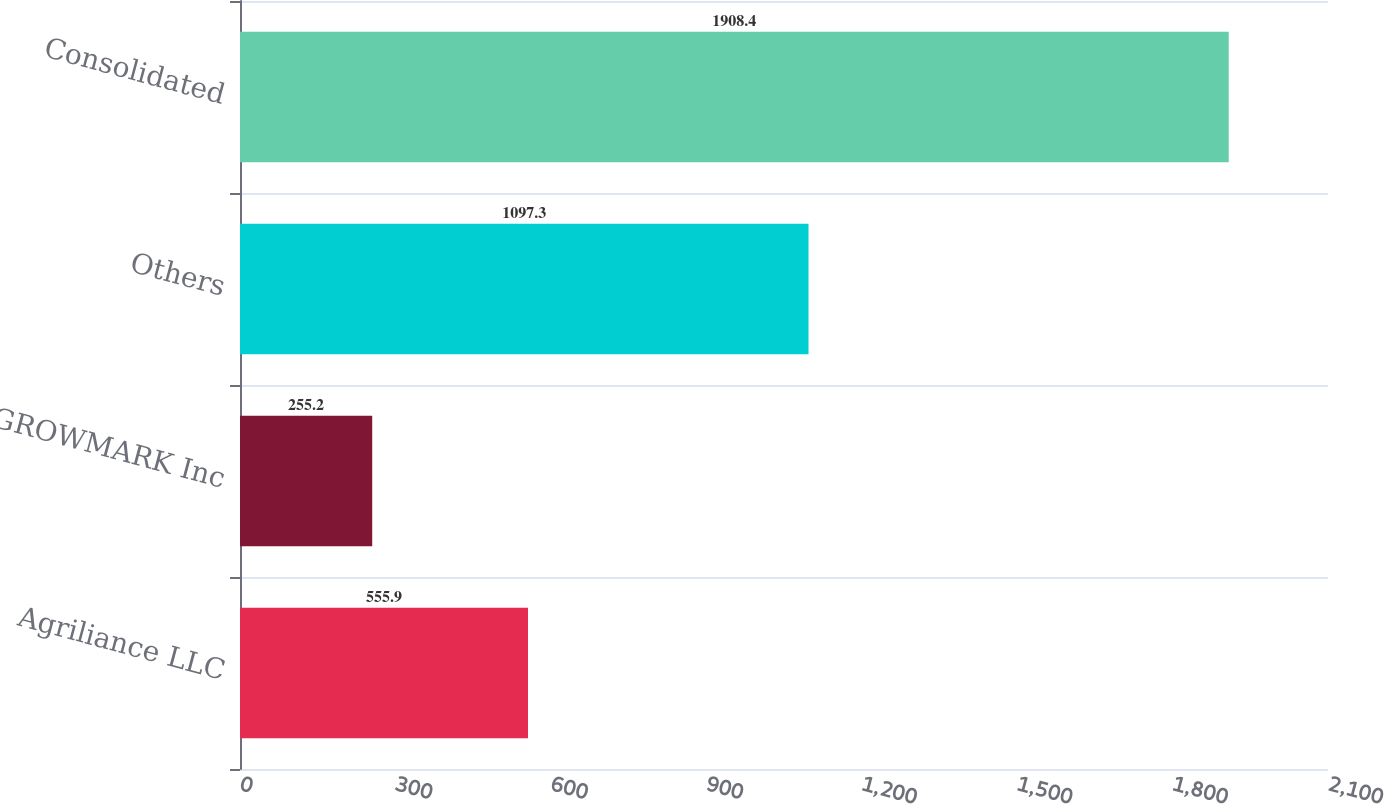Convert chart. <chart><loc_0><loc_0><loc_500><loc_500><bar_chart><fcel>Agriliance LLC<fcel>GROWMARK Inc<fcel>Others<fcel>Consolidated<nl><fcel>555.9<fcel>255.2<fcel>1097.3<fcel>1908.4<nl></chart> 